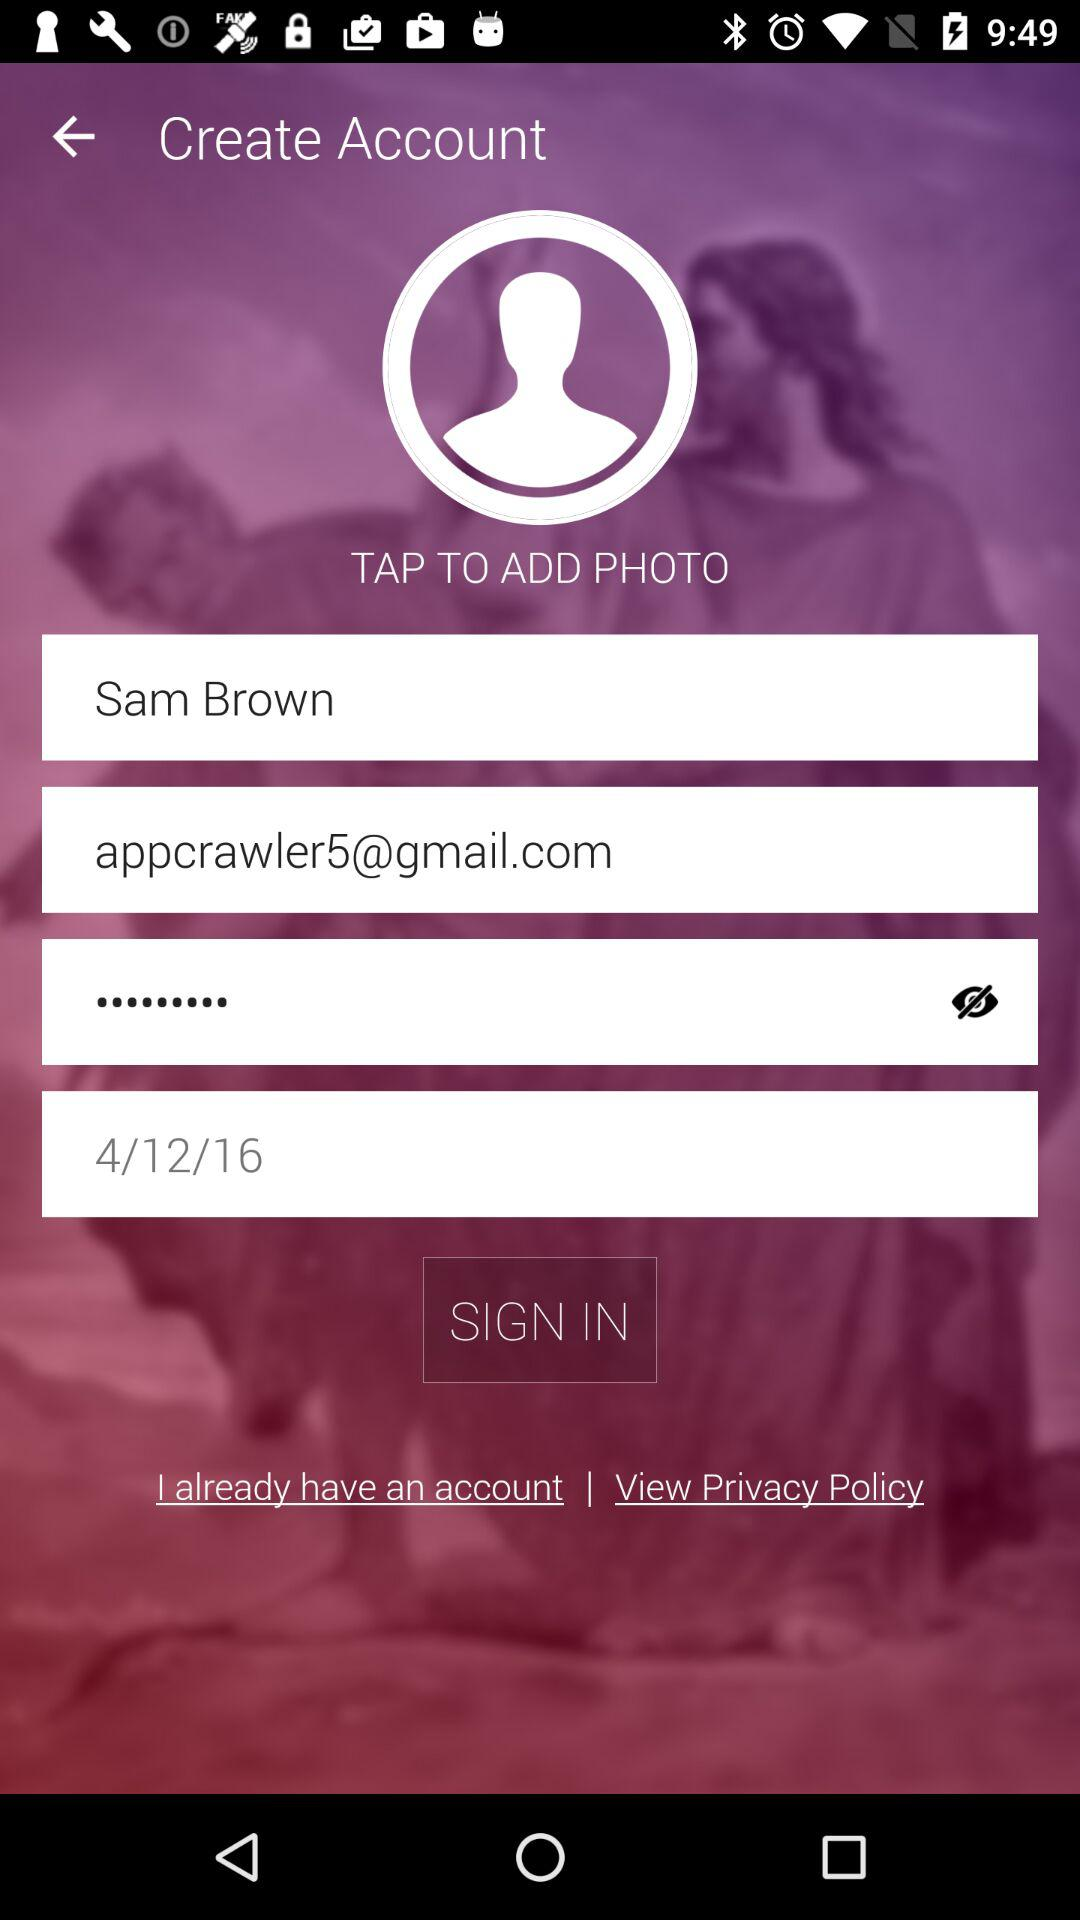What is the email address? The email address is appcrawler5@gmail.com. 